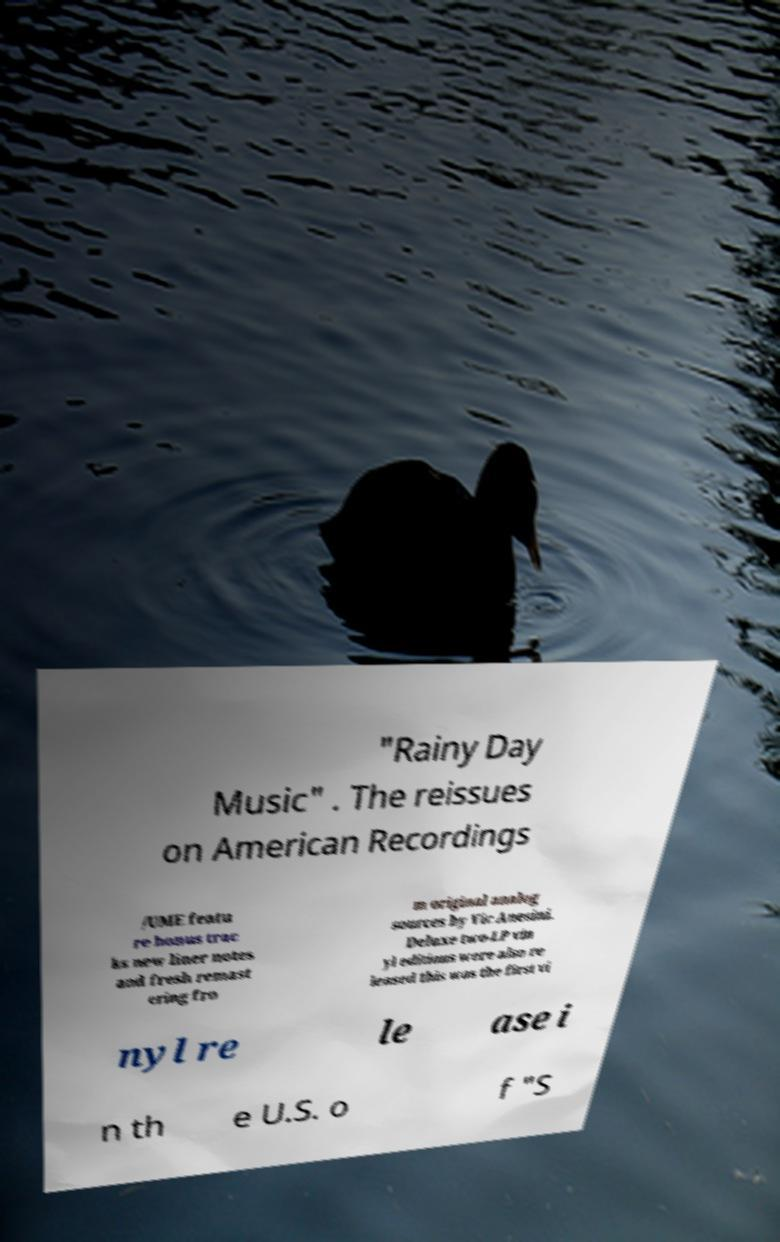Can you read and provide the text displayed in the image?This photo seems to have some interesting text. Can you extract and type it out for me? "Rainy Day Music" . The reissues on American Recordings /UME featu re bonus trac ks new liner notes and fresh remast ering fro m original analog sources by Vic Anesini. Deluxe two-LP vin yl editions were also re leased this was the first vi nyl re le ase i n th e U.S. o f "S 